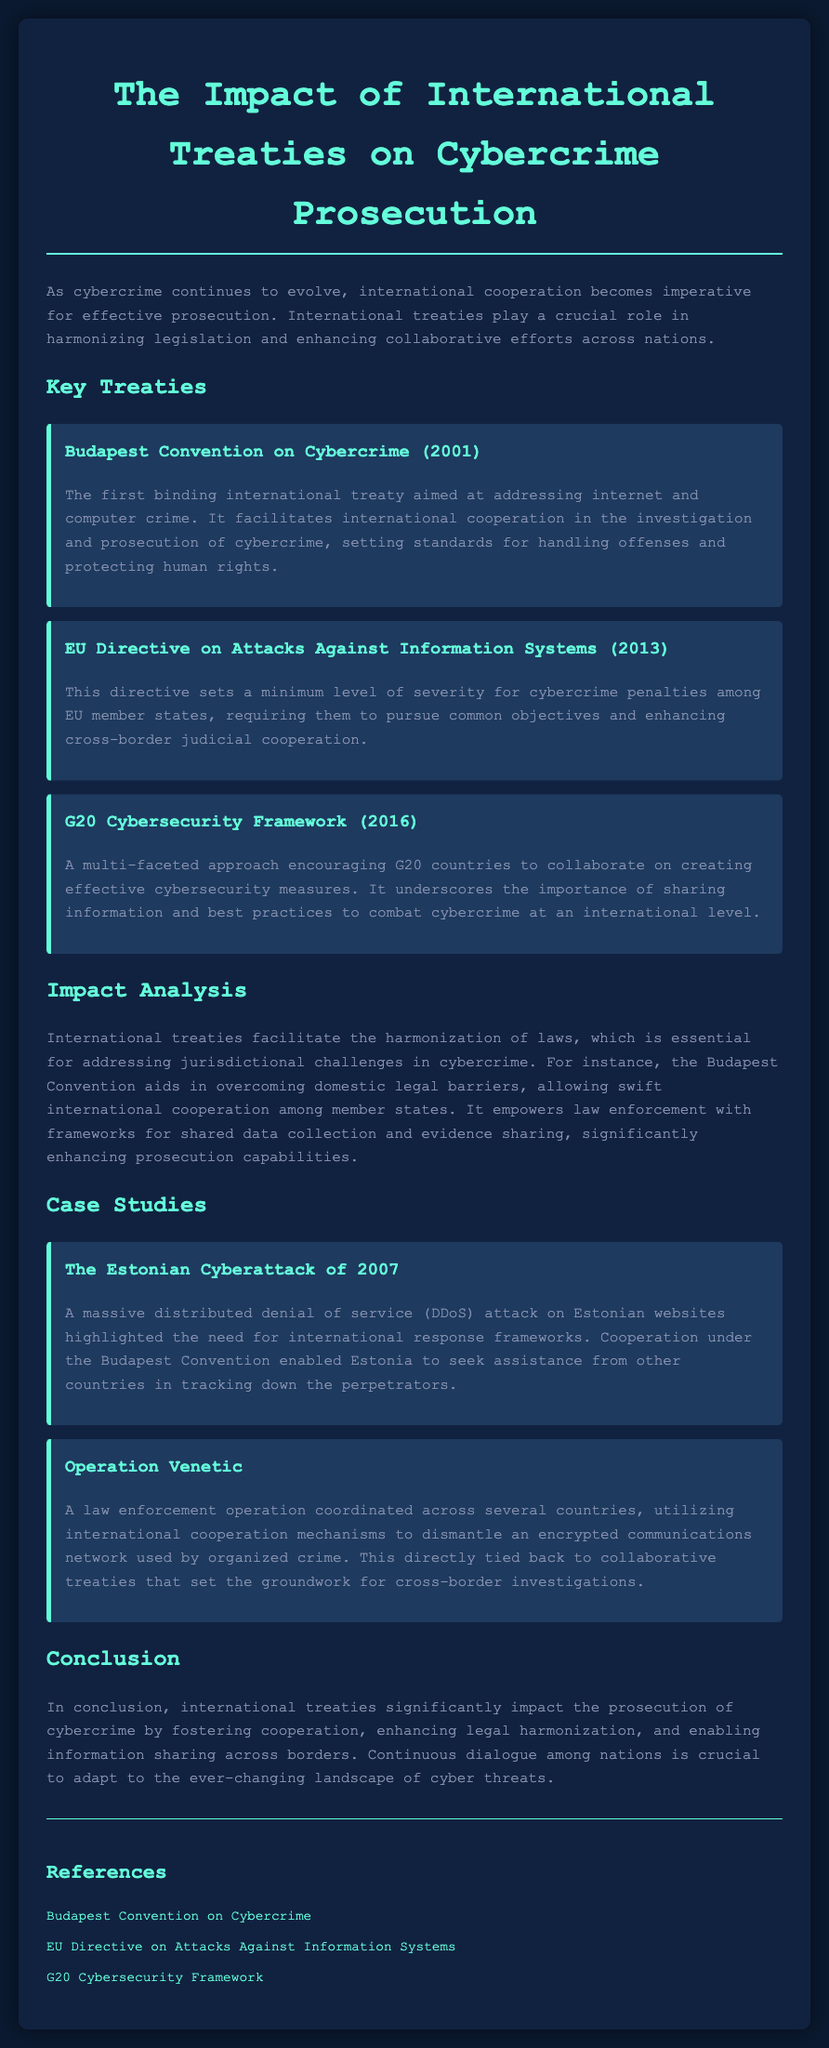What is the title of the document? The title of the document is mentioned at the top and provides a clear indication of its content.
Answer: The Impact of International Treaties on Cybercrime Prosecution What year was the Budapest Convention on Cybercrime established? The document specifies the year the Budapest Convention was established.
Answer: 2001 What is the main objective of the EU Directive on Attacks Against Information Systems? The document highlights that the directive requires member states to pursue common objectives.
Answer: Minimum level of severity for cybercrime penalties What significant event is associated with the case study of the Estonian Cyberattack? The case study gives details about an event that showcased the need for international response frameworks.
Answer: DDoS attack Which international treaty encourages G20 countries to collaborate on cybersecurity measures? The document states that the G20 Cybersecurity Framework encourages collaboration among G20 countries.
Answer: G20 Cybersecurity Framework How has the Budapest Convention impacted law enforcement capabilities? The document explains that the convention empowers law enforcement with frameworks for shared data collection.
Answer: Frameworks for shared data collection What key mechanism was utilized during Operation Venetic? The document specifies the use of international cooperation mechanisms during this operation.
Answer: International cooperation mechanisms What is emphasized as crucial for adapting to cyber threats? The document concludes with a statement about the importance of ongoing discussions among nations.
Answer: Continuous dialogue among nations 